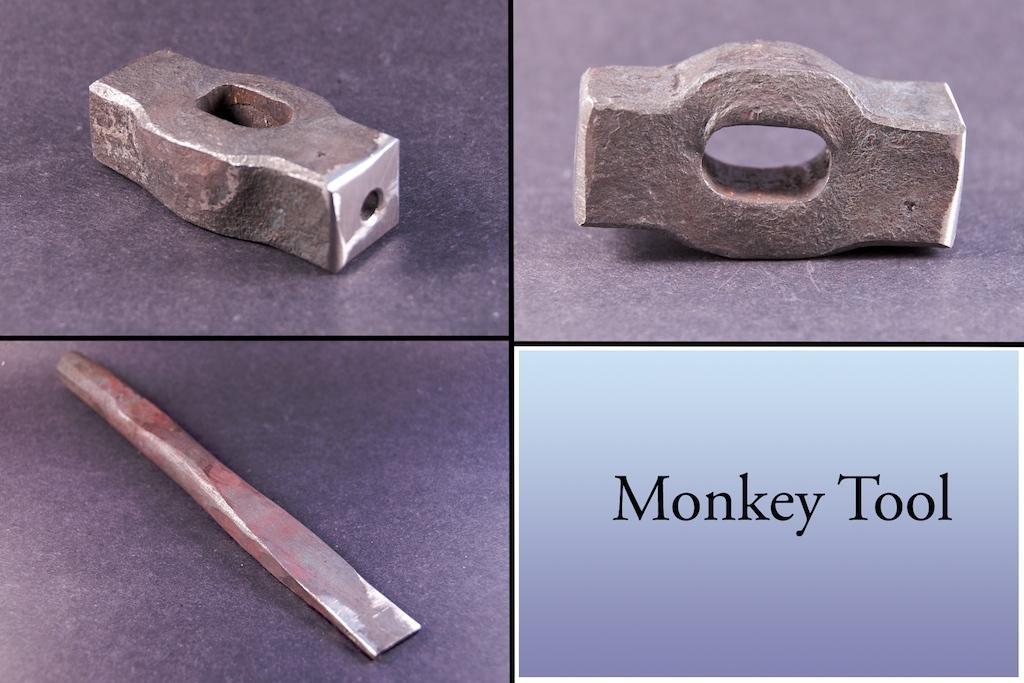What type of artwork is depicted in the image? The image is a collage. What kind of objects can be seen in the collage? There are three metal objects in the collage. Are there any words or letters in the collage? Yes, there is text present in the collage. What type of meat is being cooked over the flame in the image? There is no meat or flame present in the image; it is a collage featuring metal objects and text. 